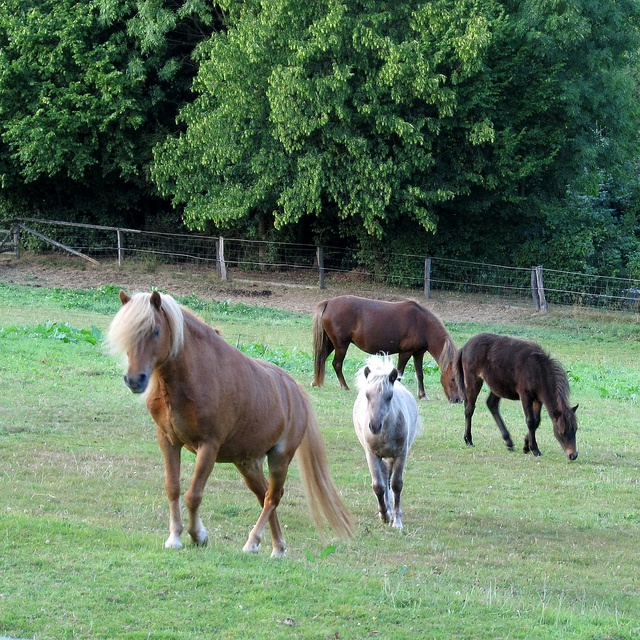Describe the objects in this image and their specific colors. I can see horse in darkgreen, gray, darkgray, and black tones, horse in darkgreen, black, gray, and darkgray tones, horse in darkgreen, black, and gray tones, and horse in darkgreen, white, gray, darkgray, and black tones in this image. 